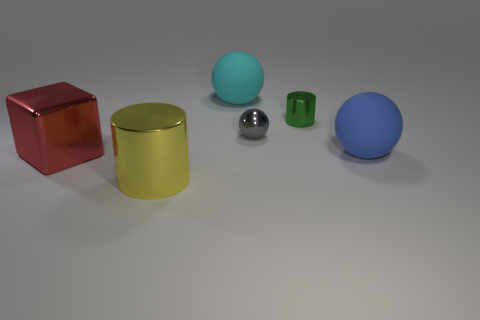Add 4 big objects. How many objects exist? 10 Subtract all cubes. How many objects are left? 5 Add 5 green cylinders. How many green cylinders are left? 6 Add 5 gray objects. How many gray objects exist? 6 Subtract 0 cyan cylinders. How many objects are left? 6 Subtract all tiny red metallic spheres. Subtract all red cubes. How many objects are left? 5 